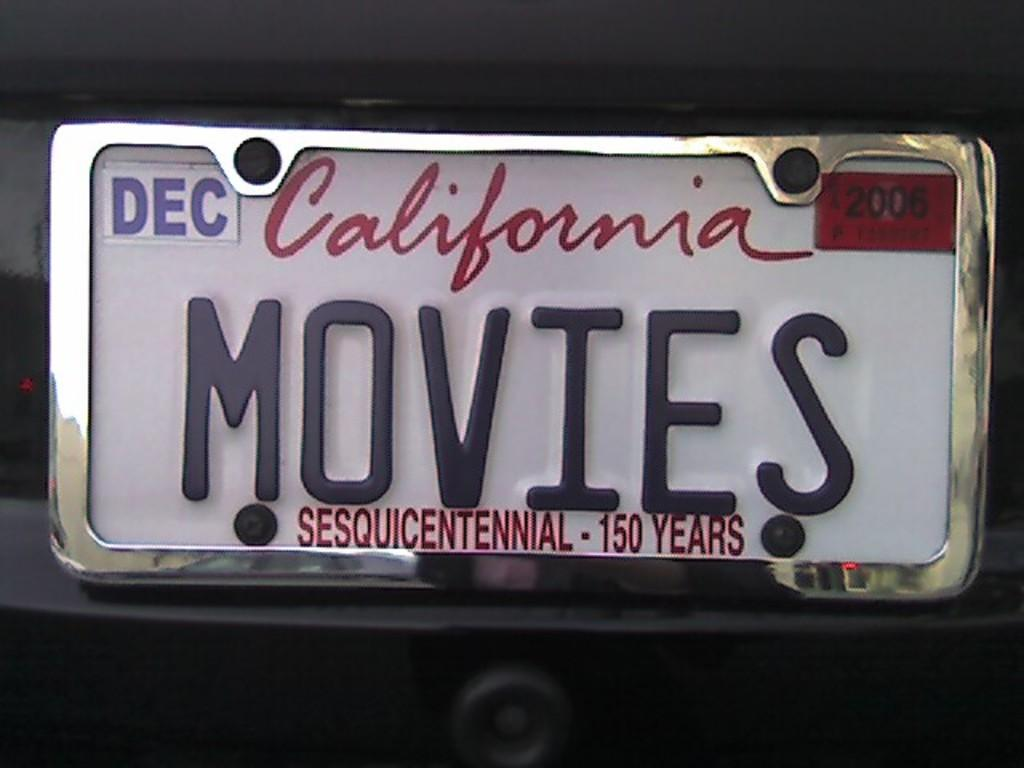<image>
Relay a brief, clear account of the picture shown. A California license plate says Movies on it. 